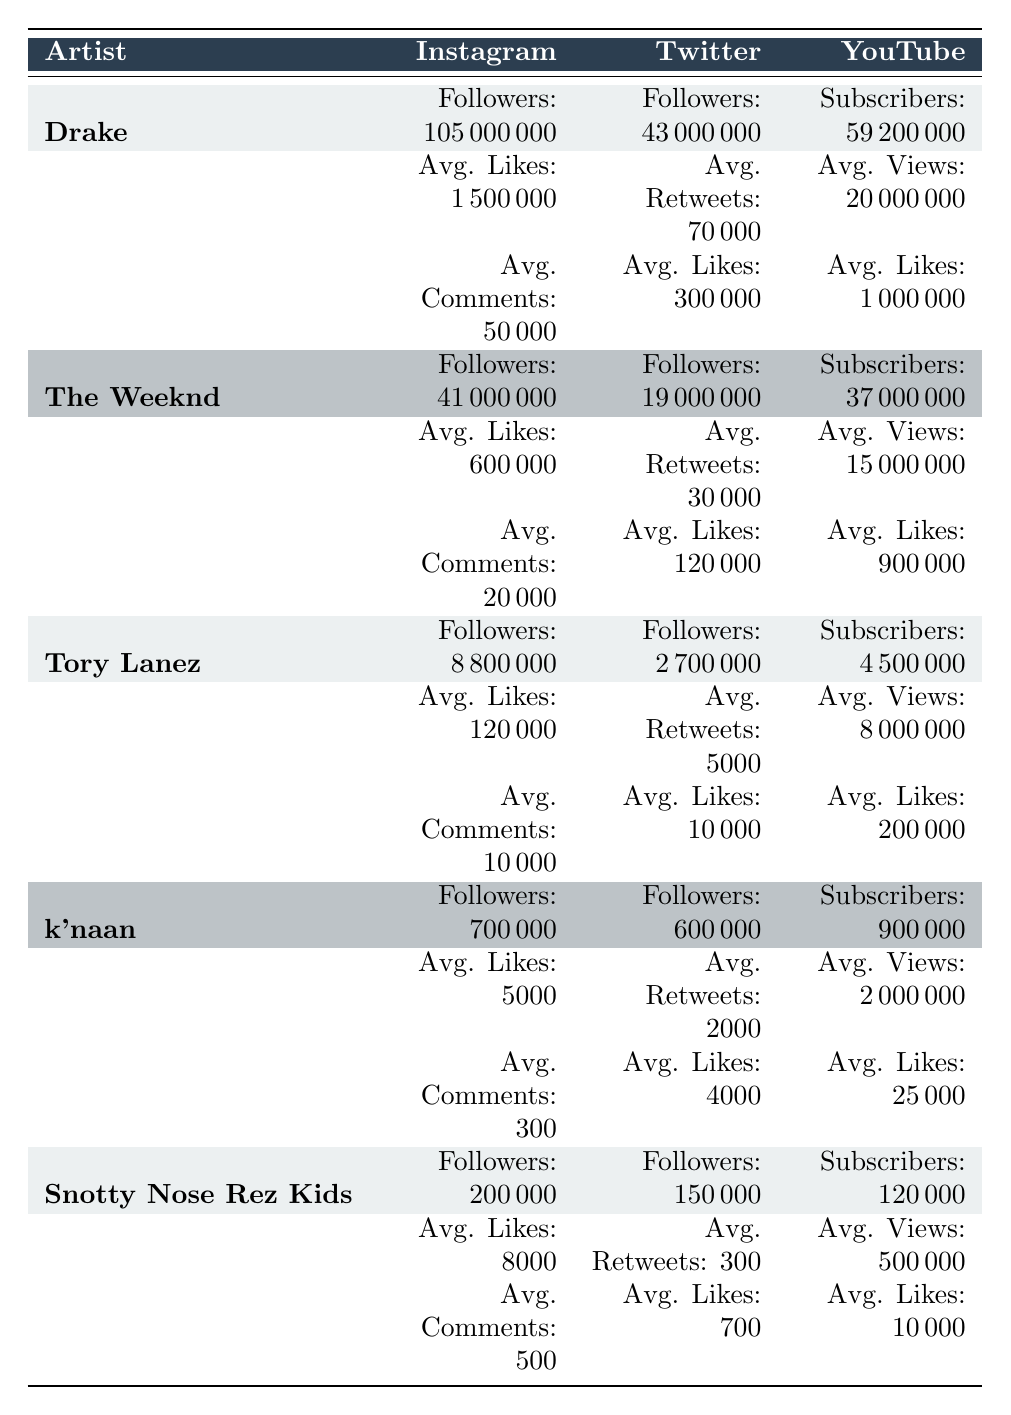What is the total number of Instagram followers for Drake and The Weeknd combined? To find the total number of Instagram followers for both artists, I sum Drake's followers (105,000,000) and The Weeknd's followers (41,000,000). This gives 105,000,000 + 41,000,000 = 146,000,000.
Answer: 146,000,000 Is Tory Lanez's average likes on Instagram higher than his average likes on Twitter? Looking at the table, Tory Lanez has average likes of 120,000 on Instagram and 10,000 on Twitter. Since 120,000 is greater than 10,000, the statement is true.
Answer: Yes Which artist has the highest average views on YouTube? I compare the average views on YouTube for each artist: Drake (20,000,000), The Weeknd (15,000,000), Tory Lanez (8,000,000), k'naan (2,000,000), and Snotty Nose Rez Kids (500,000). Drake has the highest with 20,000,000.
Answer: Drake What is the average number of followers on Twitter for all the artists listed? I first calculate the total number of Twitter followers by adding up: Drake (43,000,000), The Weeknd (19,000,000), Tory Lanez (2,700,000), k'naan (600,000), and Snotty Nose Rez Kids (150,000), which totals 65,450,000 followers. Then, I divide by the number of artists (5): 65,450,000 / 5 = 13,090,000.
Answer: 13,090,000 Does k'naan have more average likes on Instagram than Snotty Nose Rez Kids? Checking the average likes, k'naan has 5,000 on Instagram and Snotty Nose Rez Kids has 8,000. Since 5,000 is less than 8,000, the answer is false.
Answer: No What is the difference in average likes on YouTube between Drake and Tory Lanez? I subtract Tory Lanez's average likes (200,000) from Drake's average likes (1,000,000): 1,000,000 - 200,000 = 800,000. This indicates that Drake has 800,000 more average likes on YouTube than Tory Lanez.
Answer: 800,000 How many comments does The Weeknd typically receive on his Instagram posts? According to the table, The Weeknd typically receives 20,000 comments on Instagram.
Answer: 20,000 Is the number of subscribers on YouTube for k'naan greater than for Snotty Nose Rez Kids? k'naan has 900,000 subscribers on YouTube, while Snotty Nose Rez Kids has 120,000. Since 900,000 is greater than 120,000, the answer is yes.
Answer: Yes 